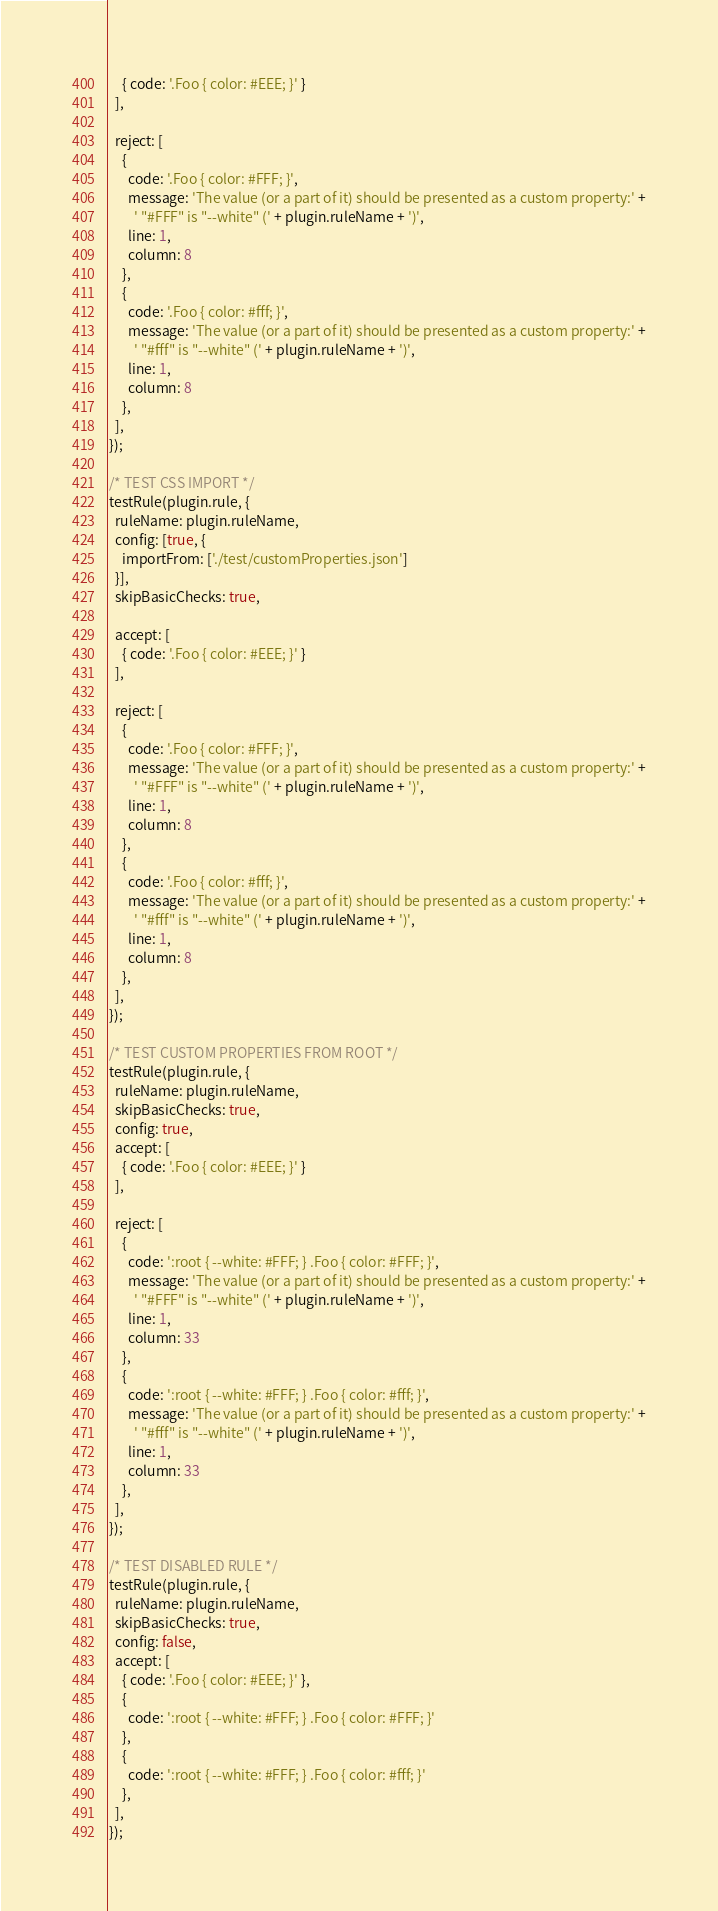<code> <loc_0><loc_0><loc_500><loc_500><_JavaScript_>    { code: '.Foo { color: #EEE; }' }
  ],

  reject: [
    {
      code: '.Foo { color: #FFF; }',
      message: 'The value (or a part of it) should be presented as a custom property:' +
        ' "#FFF" is "--white" (' + plugin.ruleName + ')',
      line: 1,
      column: 8
    },
    {
      code: '.Foo { color: #fff; }',
      message: 'The value (or a part of it) should be presented as a custom property:' +
        ' "#fff" is "--white" (' + plugin.ruleName + ')',
      line: 1,
      column: 8
    },
  ],
});

/* TEST CSS IMPORT */
testRule(plugin.rule, {
  ruleName: plugin.ruleName,
  config: [true, {
    importFrom: ['./test/customProperties.json']
  }],
  skipBasicChecks: true,

  accept: [
    { code: '.Foo { color: #EEE; }' }
  ],

  reject: [
    {
      code: '.Foo { color: #FFF; }',
      message: 'The value (or a part of it) should be presented as a custom property:' +
        ' "#FFF" is "--white" (' + plugin.ruleName + ')',
      line: 1,
      column: 8
    },
    {
      code: '.Foo { color: #fff; }',
      message: 'The value (or a part of it) should be presented as a custom property:' +
        ' "#fff" is "--white" (' + plugin.ruleName + ')',
      line: 1,
      column: 8
    },
  ],
});

/* TEST CUSTOM PROPERTIES FROM ROOT */
testRule(plugin.rule, {
  ruleName: plugin.ruleName,
  skipBasicChecks: true,
  config: true,
  accept: [
    { code: '.Foo { color: #EEE; }' }
  ],

  reject: [
    {
      code: ':root { --white: #FFF; } .Foo { color: #FFF; }',
      message: 'The value (or a part of it) should be presented as a custom property:' +
        ' "#FFF" is "--white" (' + plugin.ruleName + ')',
      line: 1,
      column: 33
    },
    {
      code: ':root { --white: #FFF; } .Foo { color: #fff; }',
      message: 'The value (or a part of it) should be presented as a custom property:' +
        ' "#fff" is "--white" (' + plugin.ruleName + ')',
      line: 1,
      column: 33
    },
  ],
});

/* TEST DISABLED RULE */
testRule(plugin.rule, {
  ruleName: plugin.ruleName,
  skipBasicChecks: true,
  config: false,
  accept: [
    { code: '.Foo { color: #EEE; }' },
    {
      code: ':root { --white: #FFF; } .Foo { color: #FFF; }'
    },
    {
      code: ':root { --white: #FFF; } .Foo { color: #fff; }'
    },
  ],
});</code> 